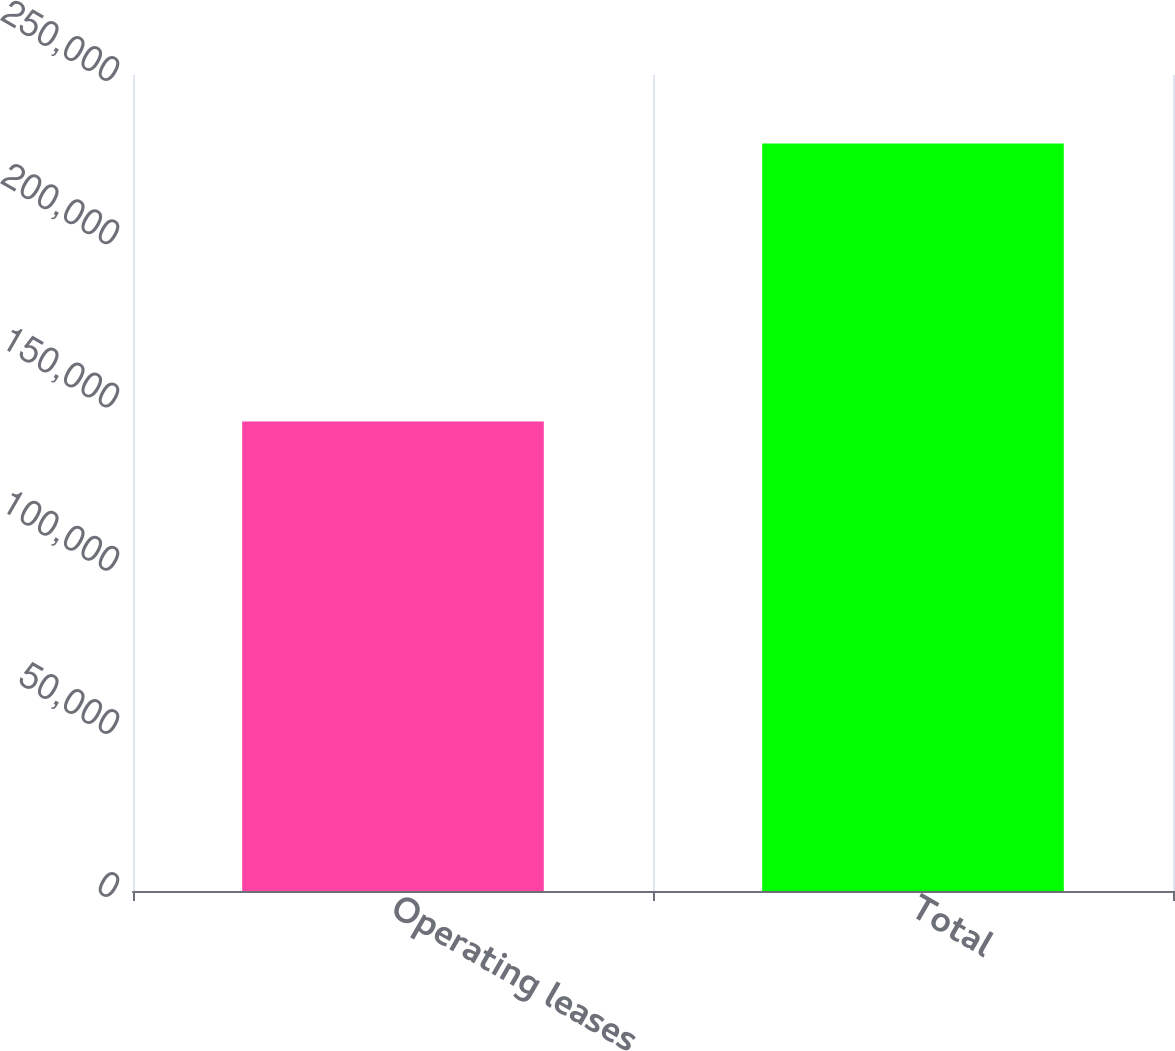Convert chart to OTSL. <chart><loc_0><loc_0><loc_500><loc_500><bar_chart><fcel>Operating leases<fcel>Total<nl><fcel>143873<fcel>228997<nl></chart> 